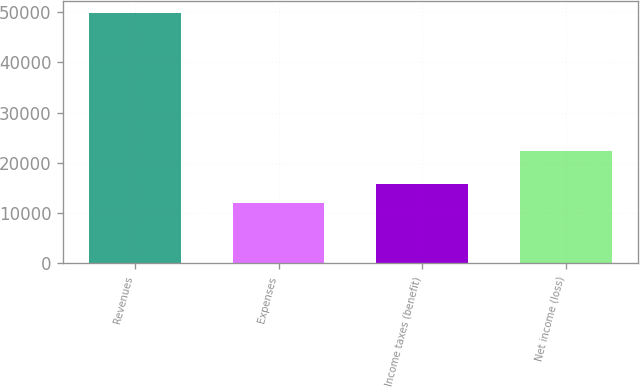Convert chart. <chart><loc_0><loc_0><loc_500><loc_500><bar_chart><fcel>Revenues<fcel>Expenses<fcel>Income taxes (benefit)<fcel>Net income (loss)<nl><fcel>49800<fcel>12014<fcel>15792.6<fcel>22411<nl></chart> 